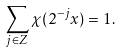Convert formula to latex. <formula><loc_0><loc_0><loc_500><loc_500>\sum _ { j \in Z } \chi ( 2 ^ { - j } x ) = 1 .</formula> 